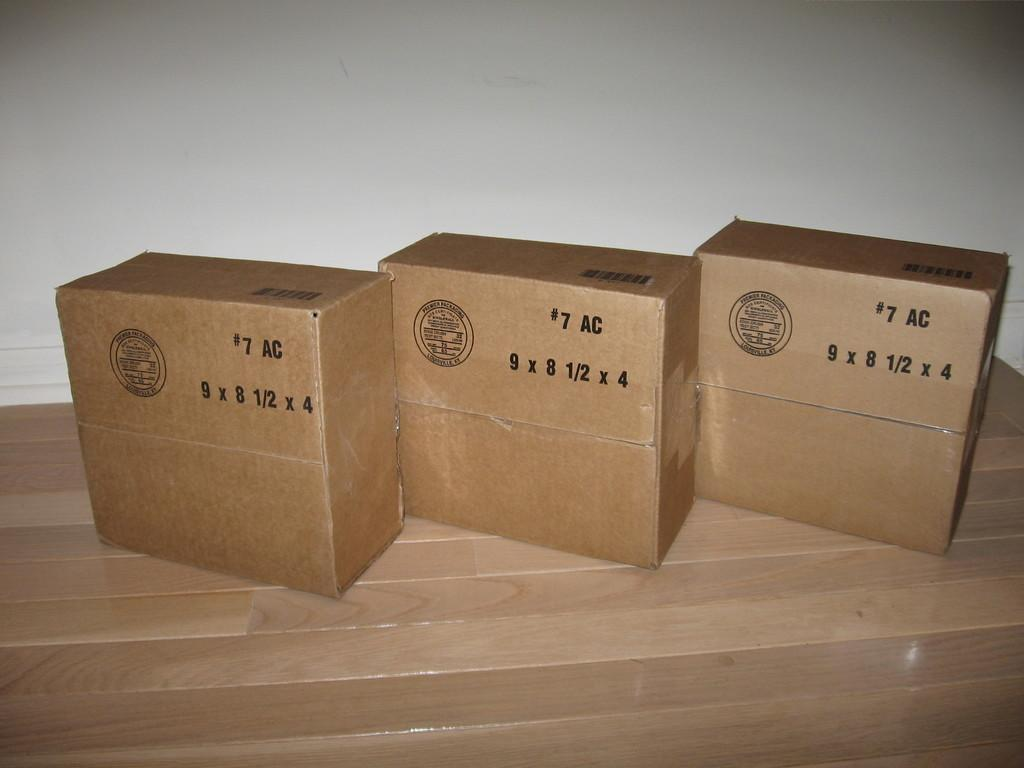<image>
Create a compact narrative representing the image presented. Three #7 AC boxes are lined up on a wooden floor. 